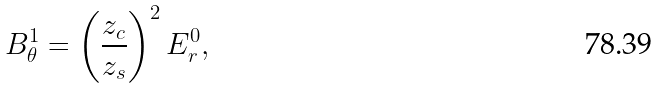<formula> <loc_0><loc_0><loc_500><loc_500>B _ { \theta } ^ { 1 } = \left ( \frac { z _ { c } } { z _ { s } } \right ) ^ { 2 } E _ { r } ^ { 0 } ,</formula> 